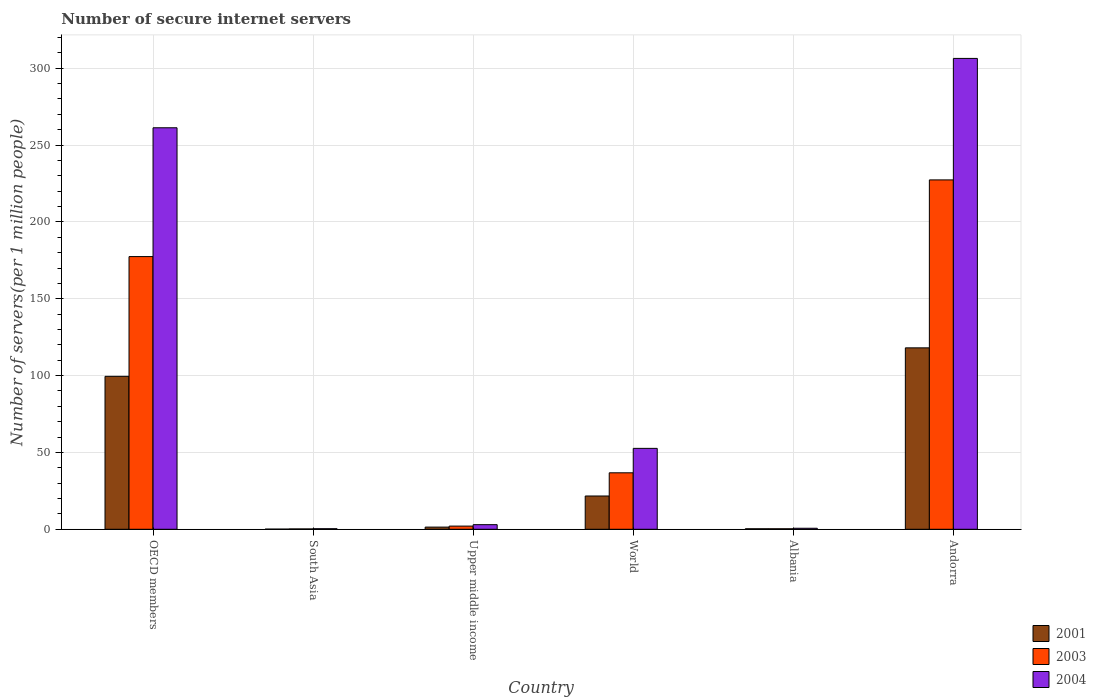How many groups of bars are there?
Offer a terse response. 6. Are the number of bars per tick equal to the number of legend labels?
Your answer should be very brief. Yes. Are the number of bars on each tick of the X-axis equal?
Give a very brief answer. Yes. What is the label of the 1st group of bars from the left?
Offer a terse response. OECD members. In how many cases, is the number of bars for a given country not equal to the number of legend labels?
Your answer should be compact. 0. What is the number of secure internet servers in 2004 in Upper middle income?
Keep it short and to the point. 3. Across all countries, what is the maximum number of secure internet servers in 2003?
Keep it short and to the point. 227.32. Across all countries, what is the minimum number of secure internet servers in 2004?
Offer a terse response. 0.36. In which country was the number of secure internet servers in 2001 maximum?
Ensure brevity in your answer.  Andorra. In which country was the number of secure internet servers in 2001 minimum?
Your answer should be very brief. South Asia. What is the total number of secure internet servers in 2001 in the graph?
Provide a succinct answer. 241.05. What is the difference between the number of secure internet servers in 2001 in Andorra and that in OECD members?
Offer a terse response. 18.53. What is the difference between the number of secure internet servers in 2001 in South Asia and the number of secure internet servers in 2004 in Albania?
Provide a succinct answer. -0.56. What is the average number of secure internet servers in 2001 per country?
Give a very brief answer. 40.17. What is the difference between the number of secure internet servers of/in 2003 and number of secure internet servers of/in 2001 in Upper middle income?
Your answer should be compact. 0.65. In how many countries, is the number of secure internet servers in 2004 greater than 40?
Provide a succinct answer. 3. What is the ratio of the number of secure internet servers in 2001 in Upper middle income to that in World?
Offer a very short reply. 0.07. Is the difference between the number of secure internet servers in 2003 in OECD members and South Asia greater than the difference between the number of secure internet servers in 2001 in OECD members and South Asia?
Your answer should be compact. Yes. What is the difference between the highest and the second highest number of secure internet servers in 2004?
Make the answer very short. 253.73. What is the difference between the highest and the lowest number of secure internet servers in 2003?
Your response must be concise. 227.1. Is the sum of the number of secure internet servers in 2003 in Albania and Upper middle income greater than the maximum number of secure internet servers in 2004 across all countries?
Give a very brief answer. No. What does the 3rd bar from the left in World represents?
Your response must be concise. 2004. How many countries are there in the graph?
Ensure brevity in your answer.  6. Are the values on the major ticks of Y-axis written in scientific E-notation?
Your answer should be very brief. No. Does the graph contain any zero values?
Offer a very short reply. No. Does the graph contain grids?
Give a very brief answer. Yes. Where does the legend appear in the graph?
Offer a terse response. Bottom right. How many legend labels are there?
Offer a very short reply. 3. What is the title of the graph?
Your answer should be compact. Number of secure internet servers. What is the label or title of the X-axis?
Make the answer very short. Country. What is the label or title of the Y-axis?
Provide a short and direct response. Number of servers(per 1 million people). What is the Number of servers(per 1 million people) in 2001 in OECD members?
Ensure brevity in your answer.  99.52. What is the Number of servers(per 1 million people) in 2003 in OECD members?
Your answer should be compact. 177.43. What is the Number of servers(per 1 million people) in 2004 in OECD members?
Provide a short and direct response. 261.25. What is the Number of servers(per 1 million people) in 2001 in South Asia?
Keep it short and to the point. 0.1. What is the Number of servers(per 1 million people) of 2003 in South Asia?
Provide a succinct answer. 0.23. What is the Number of servers(per 1 million people) in 2004 in South Asia?
Ensure brevity in your answer.  0.36. What is the Number of servers(per 1 million people) of 2001 in Upper middle income?
Provide a succinct answer. 1.41. What is the Number of servers(per 1 million people) of 2003 in Upper middle income?
Keep it short and to the point. 2.06. What is the Number of servers(per 1 million people) in 2004 in Upper middle income?
Your response must be concise. 3. What is the Number of servers(per 1 million people) in 2001 in World?
Your response must be concise. 21.65. What is the Number of servers(per 1 million people) in 2003 in World?
Provide a succinct answer. 36.75. What is the Number of servers(per 1 million people) in 2004 in World?
Your response must be concise. 52.64. What is the Number of servers(per 1 million people) in 2001 in Albania?
Make the answer very short. 0.33. What is the Number of servers(per 1 million people) of 2003 in Albania?
Keep it short and to the point. 0.33. What is the Number of servers(per 1 million people) in 2004 in Albania?
Give a very brief answer. 0.66. What is the Number of servers(per 1 million people) in 2001 in Andorra?
Offer a very short reply. 118.05. What is the Number of servers(per 1 million people) in 2003 in Andorra?
Make the answer very short. 227.32. What is the Number of servers(per 1 million people) of 2004 in Andorra?
Provide a short and direct response. 306.37. Across all countries, what is the maximum Number of servers(per 1 million people) of 2001?
Provide a short and direct response. 118.05. Across all countries, what is the maximum Number of servers(per 1 million people) in 2003?
Ensure brevity in your answer.  227.32. Across all countries, what is the maximum Number of servers(per 1 million people) in 2004?
Give a very brief answer. 306.37. Across all countries, what is the minimum Number of servers(per 1 million people) in 2001?
Provide a succinct answer. 0.1. Across all countries, what is the minimum Number of servers(per 1 million people) of 2003?
Your answer should be compact. 0.23. Across all countries, what is the minimum Number of servers(per 1 million people) in 2004?
Make the answer very short. 0.36. What is the total Number of servers(per 1 million people) in 2001 in the graph?
Provide a succinct answer. 241.05. What is the total Number of servers(per 1 million people) of 2003 in the graph?
Ensure brevity in your answer.  444.11. What is the total Number of servers(per 1 million people) in 2004 in the graph?
Keep it short and to the point. 624.28. What is the difference between the Number of servers(per 1 million people) in 2001 in OECD members and that in South Asia?
Your answer should be very brief. 99.42. What is the difference between the Number of servers(per 1 million people) of 2003 in OECD members and that in South Asia?
Give a very brief answer. 177.2. What is the difference between the Number of servers(per 1 million people) of 2004 in OECD members and that in South Asia?
Ensure brevity in your answer.  260.88. What is the difference between the Number of servers(per 1 million people) in 2001 in OECD members and that in Upper middle income?
Provide a succinct answer. 98.11. What is the difference between the Number of servers(per 1 million people) in 2003 in OECD members and that in Upper middle income?
Your answer should be very brief. 175.36. What is the difference between the Number of servers(per 1 million people) of 2004 in OECD members and that in Upper middle income?
Offer a terse response. 258.25. What is the difference between the Number of servers(per 1 million people) of 2001 in OECD members and that in World?
Make the answer very short. 77.86. What is the difference between the Number of servers(per 1 million people) in 2003 in OECD members and that in World?
Offer a terse response. 140.68. What is the difference between the Number of servers(per 1 million people) in 2004 in OECD members and that in World?
Provide a short and direct response. 208.6. What is the difference between the Number of servers(per 1 million people) in 2001 in OECD members and that in Albania?
Make the answer very short. 99.19. What is the difference between the Number of servers(per 1 million people) of 2003 in OECD members and that in Albania?
Provide a succinct answer. 177.1. What is the difference between the Number of servers(per 1 million people) of 2004 in OECD members and that in Albania?
Keep it short and to the point. 260.59. What is the difference between the Number of servers(per 1 million people) in 2001 in OECD members and that in Andorra?
Offer a terse response. -18.53. What is the difference between the Number of servers(per 1 million people) in 2003 in OECD members and that in Andorra?
Ensure brevity in your answer.  -49.9. What is the difference between the Number of servers(per 1 million people) in 2004 in OECD members and that in Andorra?
Ensure brevity in your answer.  -45.12. What is the difference between the Number of servers(per 1 million people) of 2001 in South Asia and that in Upper middle income?
Your response must be concise. -1.31. What is the difference between the Number of servers(per 1 million people) in 2003 in South Asia and that in Upper middle income?
Offer a terse response. -1.83. What is the difference between the Number of servers(per 1 million people) in 2004 in South Asia and that in Upper middle income?
Keep it short and to the point. -2.63. What is the difference between the Number of servers(per 1 million people) of 2001 in South Asia and that in World?
Your answer should be compact. -21.55. What is the difference between the Number of servers(per 1 million people) of 2003 in South Asia and that in World?
Keep it short and to the point. -36.52. What is the difference between the Number of servers(per 1 million people) in 2004 in South Asia and that in World?
Provide a succinct answer. -52.28. What is the difference between the Number of servers(per 1 million people) of 2001 in South Asia and that in Albania?
Provide a succinct answer. -0.23. What is the difference between the Number of servers(per 1 million people) of 2003 in South Asia and that in Albania?
Your answer should be compact. -0.1. What is the difference between the Number of servers(per 1 million people) of 2004 in South Asia and that in Albania?
Your answer should be compact. -0.3. What is the difference between the Number of servers(per 1 million people) in 2001 in South Asia and that in Andorra?
Your answer should be very brief. -117.95. What is the difference between the Number of servers(per 1 million people) of 2003 in South Asia and that in Andorra?
Your response must be concise. -227.1. What is the difference between the Number of servers(per 1 million people) in 2004 in South Asia and that in Andorra?
Offer a very short reply. -306. What is the difference between the Number of servers(per 1 million people) in 2001 in Upper middle income and that in World?
Ensure brevity in your answer.  -20.24. What is the difference between the Number of servers(per 1 million people) of 2003 in Upper middle income and that in World?
Offer a very short reply. -34.68. What is the difference between the Number of servers(per 1 million people) of 2004 in Upper middle income and that in World?
Give a very brief answer. -49.64. What is the difference between the Number of servers(per 1 million people) in 2001 in Upper middle income and that in Albania?
Ensure brevity in your answer.  1.08. What is the difference between the Number of servers(per 1 million people) in 2003 in Upper middle income and that in Albania?
Offer a very short reply. 1.73. What is the difference between the Number of servers(per 1 million people) of 2004 in Upper middle income and that in Albania?
Offer a very short reply. 2.34. What is the difference between the Number of servers(per 1 million people) in 2001 in Upper middle income and that in Andorra?
Ensure brevity in your answer.  -116.64. What is the difference between the Number of servers(per 1 million people) of 2003 in Upper middle income and that in Andorra?
Make the answer very short. -225.26. What is the difference between the Number of servers(per 1 million people) in 2004 in Upper middle income and that in Andorra?
Offer a very short reply. -303.37. What is the difference between the Number of servers(per 1 million people) in 2001 in World and that in Albania?
Your response must be concise. 21.33. What is the difference between the Number of servers(per 1 million people) of 2003 in World and that in Albania?
Your answer should be very brief. 36.42. What is the difference between the Number of servers(per 1 million people) in 2004 in World and that in Albania?
Offer a very short reply. 51.98. What is the difference between the Number of servers(per 1 million people) in 2001 in World and that in Andorra?
Offer a terse response. -96.39. What is the difference between the Number of servers(per 1 million people) of 2003 in World and that in Andorra?
Your response must be concise. -190.58. What is the difference between the Number of servers(per 1 million people) of 2004 in World and that in Andorra?
Provide a short and direct response. -253.73. What is the difference between the Number of servers(per 1 million people) in 2001 in Albania and that in Andorra?
Your answer should be compact. -117.72. What is the difference between the Number of servers(per 1 million people) in 2003 in Albania and that in Andorra?
Provide a short and direct response. -227. What is the difference between the Number of servers(per 1 million people) of 2004 in Albania and that in Andorra?
Keep it short and to the point. -305.71. What is the difference between the Number of servers(per 1 million people) in 2001 in OECD members and the Number of servers(per 1 million people) in 2003 in South Asia?
Keep it short and to the point. 99.29. What is the difference between the Number of servers(per 1 million people) of 2001 in OECD members and the Number of servers(per 1 million people) of 2004 in South Asia?
Your answer should be very brief. 99.15. What is the difference between the Number of servers(per 1 million people) in 2003 in OECD members and the Number of servers(per 1 million people) in 2004 in South Asia?
Your answer should be very brief. 177.06. What is the difference between the Number of servers(per 1 million people) in 2001 in OECD members and the Number of servers(per 1 million people) in 2003 in Upper middle income?
Provide a short and direct response. 97.45. What is the difference between the Number of servers(per 1 million people) in 2001 in OECD members and the Number of servers(per 1 million people) in 2004 in Upper middle income?
Make the answer very short. 96.52. What is the difference between the Number of servers(per 1 million people) of 2003 in OECD members and the Number of servers(per 1 million people) of 2004 in Upper middle income?
Ensure brevity in your answer.  174.43. What is the difference between the Number of servers(per 1 million people) of 2001 in OECD members and the Number of servers(per 1 million people) of 2003 in World?
Provide a succinct answer. 62.77. What is the difference between the Number of servers(per 1 million people) of 2001 in OECD members and the Number of servers(per 1 million people) of 2004 in World?
Give a very brief answer. 46.87. What is the difference between the Number of servers(per 1 million people) of 2003 in OECD members and the Number of servers(per 1 million people) of 2004 in World?
Your answer should be very brief. 124.78. What is the difference between the Number of servers(per 1 million people) in 2001 in OECD members and the Number of servers(per 1 million people) in 2003 in Albania?
Your response must be concise. 99.19. What is the difference between the Number of servers(per 1 million people) of 2001 in OECD members and the Number of servers(per 1 million people) of 2004 in Albania?
Offer a terse response. 98.85. What is the difference between the Number of servers(per 1 million people) of 2003 in OECD members and the Number of servers(per 1 million people) of 2004 in Albania?
Give a very brief answer. 176.77. What is the difference between the Number of servers(per 1 million people) of 2001 in OECD members and the Number of servers(per 1 million people) of 2003 in Andorra?
Ensure brevity in your answer.  -127.81. What is the difference between the Number of servers(per 1 million people) of 2001 in OECD members and the Number of servers(per 1 million people) of 2004 in Andorra?
Your answer should be very brief. -206.85. What is the difference between the Number of servers(per 1 million people) of 2003 in OECD members and the Number of servers(per 1 million people) of 2004 in Andorra?
Offer a very short reply. -128.94. What is the difference between the Number of servers(per 1 million people) in 2001 in South Asia and the Number of servers(per 1 million people) in 2003 in Upper middle income?
Your response must be concise. -1.96. What is the difference between the Number of servers(per 1 million people) in 2001 in South Asia and the Number of servers(per 1 million people) in 2004 in Upper middle income?
Your answer should be very brief. -2.9. What is the difference between the Number of servers(per 1 million people) of 2003 in South Asia and the Number of servers(per 1 million people) of 2004 in Upper middle income?
Provide a short and direct response. -2.77. What is the difference between the Number of servers(per 1 million people) in 2001 in South Asia and the Number of servers(per 1 million people) in 2003 in World?
Provide a succinct answer. -36.65. What is the difference between the Number of servers(per 1 million people) of 2001 in South Asia and the Number of servers(per 1 million people) of 2004 in World?
Your response must be concise. -52.54. What is the difference between the Number of servers(per 1 million people) in 2003 in South Asia and the Number of servers(per 1 million people) in 2004 in World?
Your answer should be very brief. -52.41. What is the difference between the Number of servers(per 1 million people) in 2001 in South Asia and the Number of servers(per 1 million people) in 2003 in Albania?
Your answer should be very brief. -0.23. What is the difference between the Number of servers(per 1 million people) of 2001 in South Asia and the Number of servers(per 1 million people) of 2004 in Albania?
Offer a very short reply. -0.56. What is the difference between the Number of servers(per 1 million people) in 2003 in South Asia and the Number of servers(per 1 million people) in 2004 in Albania?
Offer a very short reply. -0.43. What is the difference between the Number of servers(per 1 million people) in 2001 in South Asia and the Number of servers(per 1 million people) in 2003 in Andorra?
Keep it short and to the point. -227.23. What is the difference between the Number of servers(per 1 million people) in 2001 in South Asia and the Number of servers(per 1 million people) in 2004 in Andorra?
Your answer should be very brief. -306.27. What is the difference between the Number of servers(per 1 million people) in 2003 in South Asia and the Number of servers(per 1 million people) in 2004 in Andorra?
Give a very brief answer. -306.14. What is the difference between the Number of servers(per 1 million people) of 2001 in Upper middle income and the Number of servers(per 1 million people) of 2003 in World?
Offer a terse response. -35.34. What is the difference between the Number of servers(per 1 million people) of 2001 in Upper middle income and the Number of servers(per 1 million people) of 2004 in World?
Provide a succinct answer. -51.23. What is the difference between the Number of servers(per 1 million people) of 2003 in Upper middle income and the Number of servers(per 1 million people) of 2004 in World?
Provide a short and direct response. -50.58. What is the difference between the Number of servers(per 1 million people) in 2001 in Upper middle income and the Number of servers(per 1 million people) in 2003 in Albania?
Ensure brevity in your answer.  1.08. What is the difference between the Number of servers(per 1 million people) of 2001 in Upper middle income and the Number of servers(per 1 million people) of 2004 in Albania?
Your answer should be compact. 0.75. What is the difference between the Number of servers(per 1 million people) in 2003 in Upper middle income and the Number of servers(per 1 million people) in 2004 in Albania?
Keep it short and to the point. 1.4. What is the difference between the Number of servers(per 1 million people) of 2001 in Upper middle income and the Number of servers(per 1 million people) of 2003 in Andorra?
Give a very brief answer. -225.92. What is the difference between the Number of servers(per 1 million people) in 2001 in Upper middle income and the Number of servers(per 1 million people) in 2004 in Andorra?
Offer a very short reply. -304.96. What is the difference between the Number of servers(per 1 million people) in 2003 in Upper middle income and the Number of servers(per 1 million people) in 2004 in Andorra?
Offer a very short reply. -304.31. What is the difference between the Number of servers(per 1 million people) in 2001 in World and the Number of servers(per 1 million people) in 2003 in Albania?
Make the answer very short. 21.32. What is the difference between the Number of servers(per 1 million people) of 2001 in World and the Number of servers(per 1 million people) of 2004 in Albania?
Offer a very short reply. 20.99. What is the difference between the Number of servers(per 1 million people) in 2003 in World and the Number of servers(per 1 million people) in 2004 in Albania?
Offer a very short reply. 36.08. What is the difference between the Number of servers(per 1 million people) in 2001 in World and the Number of servers(per 1 million people) in 2003 in Andorra?
Offer a very short reply. -205.67. What is the difference between the Number of servers(per 1 million people) in 2001 in World and the Number of servers(per 1 million people) in 2004 in Andorra?
Give a very brief answer. -284.72. What is the difference between the Number of servers(per 1 million people) of 2003 in World and the Number of servers(per 1 million people) of 2004 in Andorra?
Keep it short and to the point. -269.62. What is the difference between the Number of servers(per 1 million people) of 2001 in Albania and the Number of servers(per 1 million people) of 2003 in Andorra?
Make the answer very short. -227. What is the difference between the Number of servers(per 1 million people) in 2001 in Albania and the Number of servers(per 1 million people) in 2004 in Andorra?
Offer a terse response. -306.04. What is the difference between the Number of servers(per 1 million people) in 2003 in Albania and the Number of servers(per 1 million people) in 2004 in Andorra?
Your answer should be compact. -306.04. What is the average Number of servers(per 1 million people) of 2001 per country?
Ensure brevity in your answer.  40.17. What is the average Number of servers(per 1 million people) of 2003 per country?
Your answer should be very brief. 74.02. What is the average Number of servers(per 1 million people) of 2004 per country?
Give a very brief answer. 104.05. What is the difference between the Number of servers(per 1 million people) in 2001 and Number of servers(per 1 million people) in 2003 in OECD members?
Offer a terse response. -77.91. What is the difference between the Number of servers(per 1 million people) of 2001 and Number of servers(per 1 million people) of 2004 in OECD members?
Your answer should be very brief. -161.73. What is the difference between the Number of servers(per 1 million people) of 2003 and Number of servers(per 1 million people) of 2004 in OECD members?
Offer a very short reply. -83.82. What is the difference between the Number of servers(per 1 million people) of 2001 and Number of servers(per 1 million people) of 2003 in South Asia?
Make the answer very short. -0.13. What is the difference between the Number of servers(per 1 million people) of 2001 and Number of servers(per 1 million people) of 2004 in South Asia?
Provide a succinct answer. -0.27. What is the difference between the Number of servers(per 1 million people) of 2003 and Number of servers(per 1 million people) of 2004 in South Asia?
Provide a succinct answer. -0.14. What is the difference between the Number of servers(per 1 million people) of 2001 and Number of servers(per 1 million people) of 2003 in Upper middle income?
Your answer should be very brief. -0.65. What is the difference between the Number of servers(per 1 million people) in 2001 and Number of servers(per 1 million people) in 2004 in Upper middle income?
Your answer should be very brief. -1.59. What is the difference between the Number of servers(per 1 million people) of 2003 and Number of servers(per 1 million people) of 2004 in Upper middle income?
Keep it short and to the point. -0.94. What is the difference between the Number of servers(per 1 million people) of 2001 and Number of servers(per 1 million people) of 2003 in World?
Your answer should be very brief. -15.09. What is the difference between the Number of servers(per 1 million people) of 2001 and Number of servers(per 1 million people) of 2004 in World?
Your response must be concise. -30.99. What is the difference between the Number of servers(per 1 million people) of 2003 and Number of servers(per 1 million people) of 2004 in World?
Offer a very short reply. -15.9. What is the difference between the Number of servers(per 1 million people) of 2001 and Number of servers(per 1 million people) of 2003 in Albania?
Your response must be concise. -0. What is the difference between the Number of servers(per 1 million people) in 2001 and Number of servers(per 1 million people) in 2004 in Albania?
Keep it short and to the point. -0.33. What is the difference between the Number of servers(per 1 million people) of 2003 and Number of servers(per 1 million people) of 2004 in Albania?
Your answer should be compact. -0.33. What is the difference between the Number of servers(per 1 million people) in 2001 and Number of servers(per 1 million people) in 2003 in Andorra?
Provide a succinct answer. -109.28. What is the difference between the Number of servers(per 1 million people) of 2001 and Number of servers(per 1 million people) of 2004 in Andorra?
Make the answer very short. -188.32. What is the difference between the Number of servers(per 1 million people) of 2003 and Number of servers(per 1 million people) of 2004 in Andorra?
Your response must be concise. -79.04. What is the ratio of the Number of servers(per 1 million people) of 2001 in OECD members to that in South Asia?
Your answer should be very brief. 1006.76. What is the ratio of the Number of servers(per 1 million people) in 2003 in OECD members to that in South Asia?
Provide a short and direct response. 778.31. What is the ratio of the Number of servers(per 1 million people) in 2004 in OECD members to that in South Asia?
Provide a succinct answer. 717.42. What is the ratio of the Number of servers(per 1 million people) in 2001 in OECD members to that in Upper middle income?
Provide a succinct answer. 70.62. What is the ratio of the Number of servers(per 1 million people) of 2003 in OECD members to that in Upper middle income?
Your answer should be compact. 86.09. What is the ratio of the Number of servers(per 1 million people) of 2004 in OECD members to that in Upper middle income?
Make the answer very short. 87.2. What is the ratio of the Number of servers(per 1 million people) in 2001 in OECD members to that in World?
Offer a very short reply. 4.6. What is the ratio of the Number of servers(per 1 million people) of 2003 in OECD members to that in World?
Your response must be concise. 4.83. What is the ratio of the Number of servers(per 1 million people) in 2004 in OECD members to that in World?
Your response must be concise. 4.96. What is the ratio of the Number of servers(per 1 million people) of 2001 in OECD members to that in Albania?
Keep it short and to the point. 304.53. What is the ratio of the Number of servers(per 1 million people) of 2003 in OECD members to that in Albania?
Offer a very short reply. 539.31. What is the ratio of the Number of servers(per 1 million people) in 2004 in OECD members to that in Albania?
Offer a terse response. 395.39. What is the ratio of the Number of servers(per 1 million people) of 2001 in OECD members to that in Andorra?
Your answer should be compact. 0.84. What is the ratio of the Number of servers(per 1 million people) in 2003 in OECD members to that in Andorra?
Your answer should be compact. 0.78. What is the ratio of the Number of servers(per 1 million people) in 2004 in OECD members to that in Andorra?
Keep it short and to the point. 0.85. What is the ratio of the Number of servers(per 1 million people) of 2001 in South Asia to that in Upper middle income?
Provide a succinct answer. 0.07. What is the ratio of the Number of servers(per 1 million people) in 2003 in South Asia to that in Upper middle income?
Ensure brevity in your answer.  0.11. What is the ratio of the Number of servers(per 1 million people) in 2004 in South Asia to that in Upper middle income?
Provide a succinct answer. 0.12. What is the ratio of the Number of servers(per 1 million people) of 2001 in South Asia to that in World?
Offer a very short reply. 0. What is the ratio of the Number of servers(per 1 million people) in 2003 in South Asia to that in World?
Offer a terse response. 0.01. What is the ratio of the Number of servers(per 1 million people) of 2004 in South Asia to that in World?
Your response must be concise. 0.01. What is the ratio of the Number of servers(per 1 million people) of 2001 in South Asia to that in Albania?
Keep it short and to the point. 0.3. What is the ratio of the Number of servers(per 1 million people) of 2003 in South Asia to that in Albania?
Your response must be concise. 0.69. What is the ratio of the Number of servers(per 1 million people) in 2004 in South Asia to that in Albania?
Offer a terse response. 0.55. What is the ratio of the Number of servers(per 1 million people) in 2001 in South Asia to that in Andorra?
Your answer should be very brief. 0. What is the ratio of the Number of servers(per 1 million people) of 2004 in South Asia to that in Andorra?
Your answer should be very brief. 0. What is the ratio of the Number of servers(per 1 million people) of 2001 in Upper middle income to that in World?
Your response must be concise. 0.07. What is the ratio of the Number of servers(per 1 million people) in 2003 in Upper middle income to that in World?
Your response must be concise. 0.06. What is the ratio of the Number of servers(per 1 million people) in 2004 in Upper middle income to that in World?
Your answer should be very brief. 0.06. What is the ratio of the Number of servers(per 1 million people) of 2001 in Upper middle income to that in Albania?
Keep it short and to the point. 4.31. What is the ratio of the Number of servers(per 1 million people) of 2003 in Upper middle income to that in Albania?
Give a very brief answer. 6.26. What is the ratio of the Number of servers(per 1 million people) in 2004 in Upper middle income to that in Albania?
Your answer should be compact. 4.53. What is the ratio of the Number of servers(per 1 million people) of 2001 in Upper middle income to that in Andorra?
Offer a very short reply. 0.01. What is the ratio of the Number of servers(per 1 million people) of 2003 in Upper middle income to that in Andorra?
Give a very brief answer. 0.01. What is the ratio of the Number of servers(per 1 million people) of 2004 in Upper middle income to that in Andorra?
Offer a very short reply. 0.01. What is the ratio of the Number of servers(per 1 million people) in 2001 in World to that in Albania?
Your answer should be very brief. 66.26. What is the ratio of the Number of servers(per 1 million people) of 2003 in World to that in Albania?
Offer a very short reply. 111.69. What is the ratio of the Number of servers(per 1 million people) of 2004 in World to that in Albania?
Your answer should be compact. 79.67. What is the ratio of the Number of servers(per 1 million people) in 2001 in World to that in Andorra?
Your answer should be very brief. 0.18. What is the ratio of the Number of servers(per 1 million people) in 2003 in World to that in Andorra?
Your answer should be very brief. 0.16. What is the ratio of the Number of servers(per 1 million people) in 2004 in World to that in Andorra?
Your answer should be very brief. 0.17. What is the ratio of the Number of servers(per 1 million people) of 2001 in Albania to that in Andorra?
Keep it short and to the point. 0. What is the ratio of the Number of servers(per 1 million people) of 2003 in Albania to that in Andorra?
Provide a succinct answer. 0. What is the ratio of the Number of servers(per 1 million people) of 2004 in Albania to that in Andorra?
Give a very brief answer. 0. What is the difference between the highest and the second highest Number of servers(per 1 million people) in 2001?
Make the answer very short. 18.53. What is the difference between the highest and the second highest Number of servers(per 1 million people) in 2003?
Offer a very short reply. 49.9. What is the difference between the highest and the second highest Number of servers(per 1 million people) in 2004?
Ensure brevity in your answer.  45.12. What is the difference between the highest and the lowest Number of servers(per 1 million people) in 2001?
Ensure brevity in your answer.  117.95. What is the difference between the highest and the lowest Number of servers(per 1 million people) in 2003?
Keep it short and to the point. 227.1. What is the difference between the highest and the lowest Number of servers(per 1 million people) of 2004?
Your response must be concise. 306. 